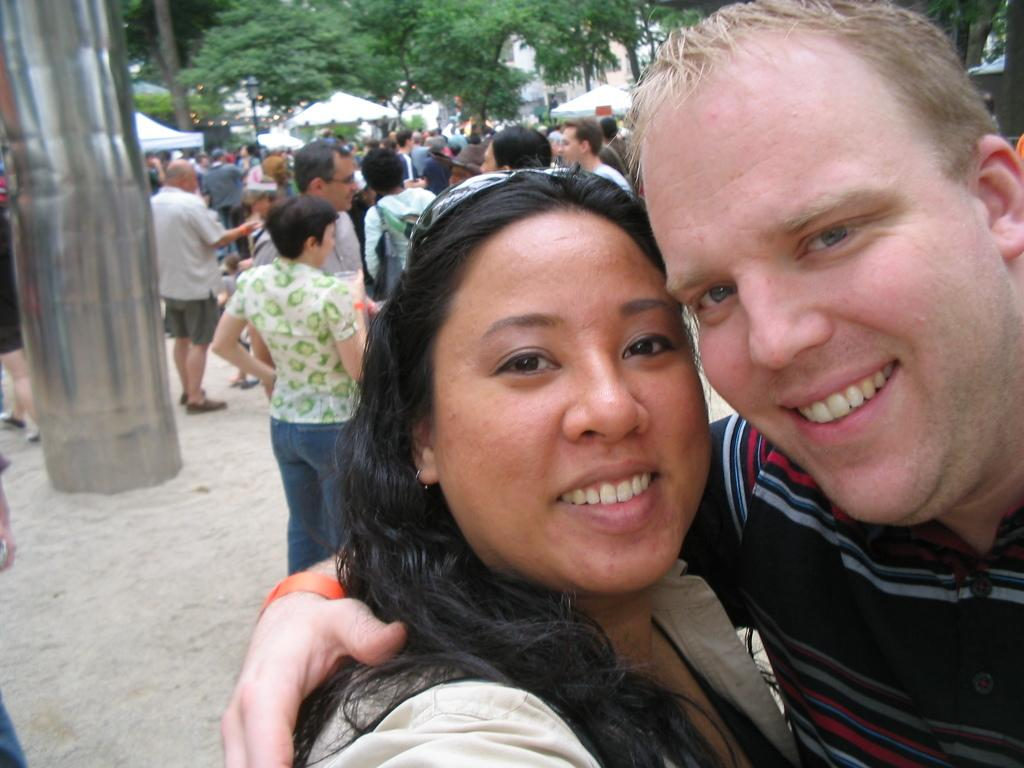Who or what can be seen in the image? There are people in the image. What type of terrain is visible in the image? There is sand visible in the image. What kind of object can be seen in the image? There is a metal object in the image. What structures are present in the background of the image? There are tents in the background of the image. What type of vegetation is visible in the background of the image? There are trees in the background of the image. What type of fruit is being harvested in the image? There is no fruit visible in the image, nor is there any indication of fruit harvesting. 